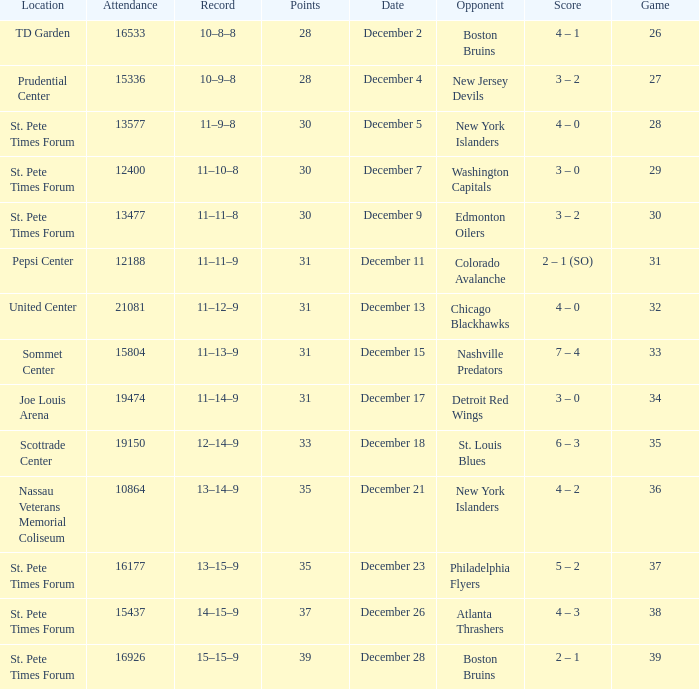Would you mind parsing the complete table? {'header': ['Location', 'Attendance', 'Record', 'Points', 'Date', 'Opponent', 'Score', 'Game'], 'rows': [['TD Garden', '16533', '10–8–8', '28', 'December 2', 'Boston Bruins', '4 – 1', '26'], ['Prudential Center', '15336', '10–9–8', '28', 'December 4', 'New Jersey Devils', '3 – 2', '27'], ['St. Pete Times Forum', '13577', '11–9–8', '30', 'December 5', 'New York Islanders', '4 – 0', '28'], ['St. Pete Times Forum', '12400', '11–10–8', '30', 'December 7', 'Washington Capitals', '3 – 0', '29'], ['St. Pete Times Forum', '13477', '11–11–8', '30', 'December 9', 'Edmonton Oilers', '3 – 2', '30'], ['Pepsi Center', '12188', '11–11–9', '31', 'December 11', 'Colorado Avalanche', '2 – 1 (SO)', '31'], ['United Center', '21081', '11–12–9', '31', 'December 13', 'Chicago Blackhawks', '4 – 0', '32'], ['Sommet Center', '15804', '11–13–9', '31', 'December 15', 'Nashville Predators', '7 – 4', '33'], ['Joe Louis Arena', '19474', '11–14–9', '31', 'December 17', 'Detroit Red Wings', '3 – 0', '34'], ['Scottrade Center', '19150', '12–14–9', '33', 'December 18', 'St. Louis Blues', '6 – 3', '35'], ['Nassau Veterans Memorial Coliseum', '10864', '13–14–9', '35', 'December 21', 'New York Islanders', '4 – 2', '36'], ['St. Pete Times Forum', '16177', '13–15–9', '35', 'December 23', 'Philadelphia Flyers', '5 – 2', '37'], ['St. Pete Times Forum', '15437', '14–15–9', '37', 'December 26', 'Atlanta Thrashers', '4 – 3', '38'], ['St. Pete Times Forum', '16926', '15–15–9', '39', 'December 28', 'Boston Bruins', '2 – 1', '39']]} What was the largest attended game? 21081.0. 